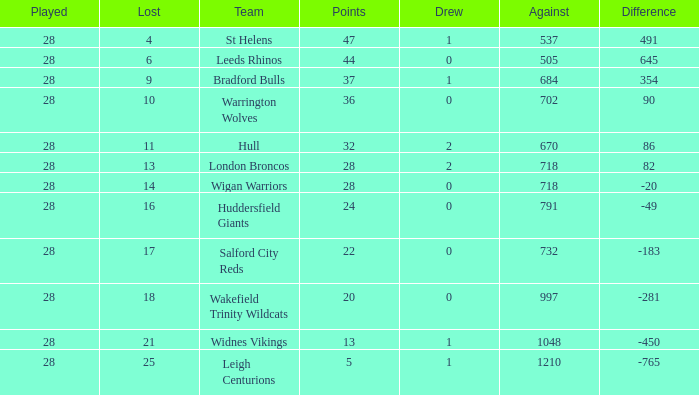What is the average points for a team that lost 4 and played more than 28 games? None. 